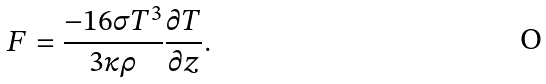Convert formula to latex. <formula><loc_0><loc_0><loc_500><loc_500>F = \frac { - 1 6 \sigma T ^ { 3 } } { 3 \kappa \rho } \frac { \partial T } { \partial z } .</formula> 